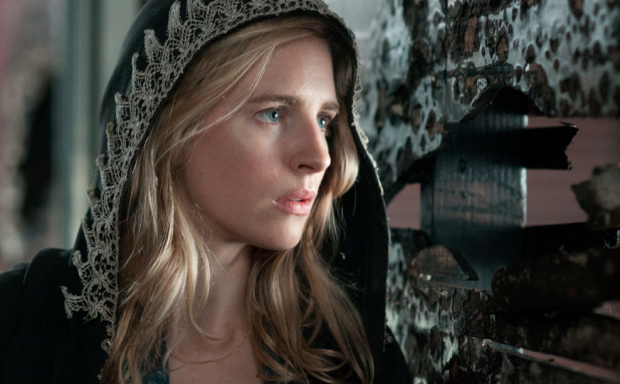Could you imagine a dystopian scenario for this image? In a dystopian future, the woman in the image could be someone living in a decaying urban landscape where oppressive regimes control the populace. The once-colorful posters have been left to deteriorate as symbols of a suppressed past. She might be part of an underground resistance, trying to piece together fragments of lost history to inspire hope and revolution. Her cloak serves not only as a disguise but also as a symbol of her resistance against the tyrannical forces. Every glance over her shoulder is fueled by caution, every step driven by the hope of reclaiming freedom. What is her mission in this dystopian future? In this dystopian future, her mission is to find and protect the remnants of forbidden knowledge. She is tasked with gathering pieces of historical truth scattered across the city to reveal the roots of the authoritarian regime’s rise to power. By doing so, she hopes to ignite a spark of rebellion within the oppressed masses. Her journey is fraught with danger, as agents of the regime are always on her trail, but she is driven by an unwavering resolve to restore justice and freedom. The peeling posters serve as clues and reminders of the time before the fall, guiding her path towards uncovering the truth. 